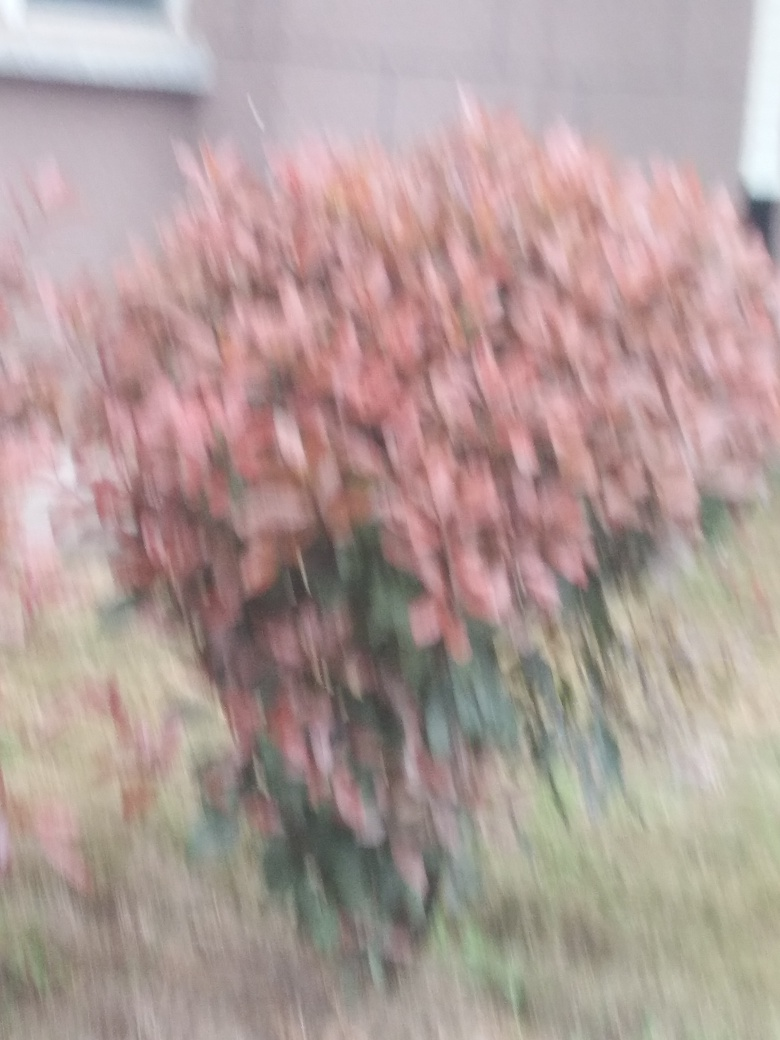What is the issue with this image quality?
A. Serious focus issues resulting in blurriness.
B. Overexposed highlights in the image.
C. Excessive noise in the image.
Answer with the option's letter from the given choices directly.
 The primary issue with this image is a significant lack of sharpness due to serious focus issues, which leads to the overall blurriness observable throughout the photo. This could arise from camera shake, an incorrect focus setting, or the subject moving rapidly. There is no strong evidence of overexposed highlights or excessive noise, so option A seems to be the most accurate. 